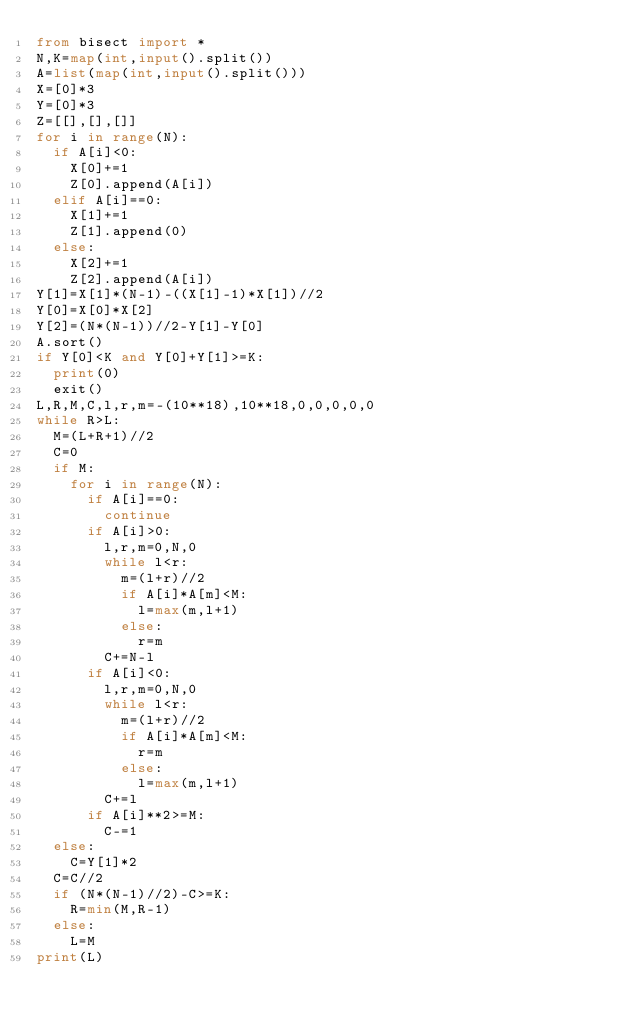<code> <loc_0><loc_0><loc_500><loc_500><_Python_>from bisect import *
N,K=map(int,input().split())
A=list(map(int,input().split()))
X=[0]*3
Y=[0]*3
Z=[[],[],[]]
for i in range(N):
  if A[i]<0:
    X[0]+=1
    Z[0].append(A[i])
  elif A[i]==0:
    X[1]+=1
    Z[1].append(0)
  else:
    X[2]+=1
    Z[2].append(A[i])
Y[1]=X[1]*(N-1)-((X[1]-1)*X[1])//2
Y[0]=X[0]*X[2]
Y[2]=(N*(N-1))//2-Y[1]-Y[0]
A.sort()
if Y[0]<K and Y[0]+Y[1]>=K:
  print(0)
  exit()
L,R,M,C,l,r,m=-(10**18),10**18,0,0,0,0,0
while R>L:
  M=(L+R+1)//2
  C=0
  if M:
    for i in range(N):
      if A[i]==0:
        continue
      if A[i]>0:
        l,r,m=0,N,0
        while l<r:
          m=(l+r)//2
          if A[i]*A[m]<M:
            l=max(m,l+1)
          else:
            r=m
        C+=N-l
      if A[i]<0:
        l,r,m=0,N,0
        while l<r:
          m=(l+r)//2
          if A[i]*A[m]<M:
            r=m
          else:
            l=max(m,l+1)
        C+=l
      if A[i]**2>=M:
        C-=1
  else:
    C=Y[1]*2
  C=C//2
  if (N*(N-1)//2)-C>=K:
    R=min(M,R-1)
  else:
    L=M
print(L)</code> 